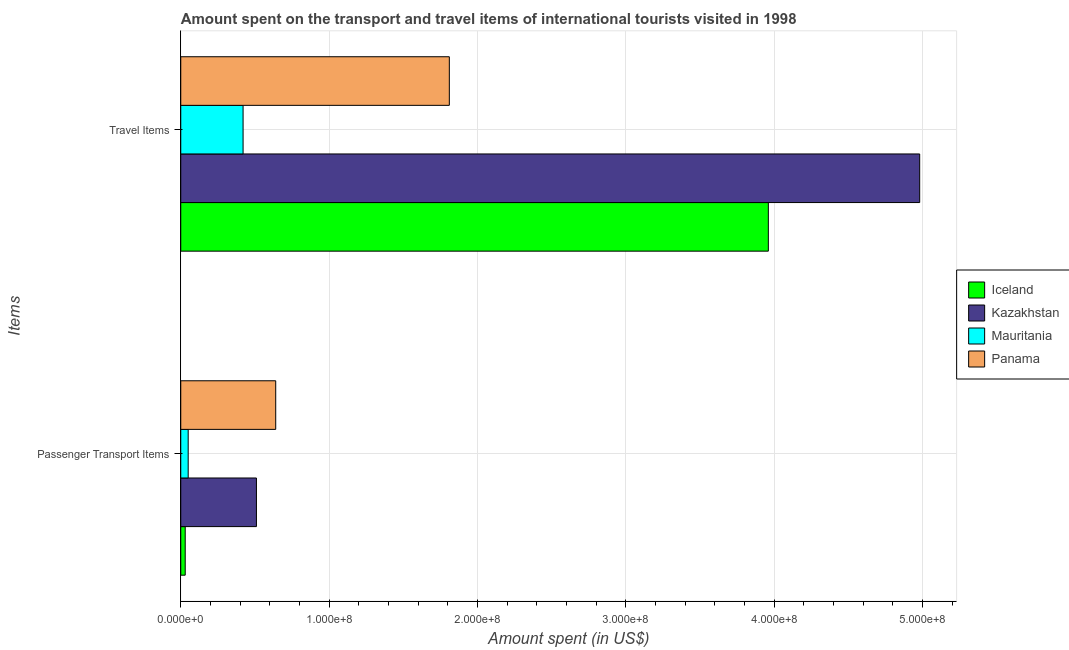How many groups of bars are there?
Offer a very short reply. 2. Are the number of bars per tick equal to the number of legend labels?
Offer a terse response. Yes. How many bars are there on the 2nd tick from the top?
Provide a succinct answer. 4. How many bars are there on the 1st tick from the bottom?
Your answer should be compact. 4. What is the label of the 2nd group of bars from the top?
Keep it short and to the point. Passenger Transport Items. What is the amount spent on passenger transport items in Mauritania?
Your response must be concise. 5.00e+06. Across all countries, what is the maximum amount spent in travel items?
Offer a terse response. 4.98e+08. Across all countries, what is the minimum amount spent on passenger transport items?
Keep it short and to the point. 3.00e+06. In which country was the amount spent in travel items maximum?
Offer a terse response. Kazakhstan. In which country was the amount spent in travel items minimum?
Offer a very short reply. Mauritania. What is the total amount spent in travel items in the graph?
Keep it short and to the point. 1.12e+09. What is the difference between the amount spent on passenger transport items in Mauritania and that in Iceland?
Your response must be concise. 2.00e+06. What is the difference between the amount spent on passenger transport items in Iceland and the amount spent in travel items in Panama?
Provide a succinct answer. -1.78e+08. What is the average amount spent on passenger transport items per country?
Provide a short and direct response. 3.08e+07. What is the difference between the amount spent in travel items and amount spent on passenger transport items in Mauritania?
Keep it short and to the point. 3.70e+07. What is the ratio of the amount spent on passenger transport items in Mauritania to that in Iceland?
Provide a succinct answer. 1.67. Is the amount spent in travel items in Mauritania less than that in Panama?
Provide a short and direct response. Yes. In how many countries, is the amount spent on passenger transport items greater than the average amount spent on passenger transport items taken over all countries?
Offer a very short reply. 2. What does the 3rd bar from the top in Passenger Transport Items represents?
Ensure brevity in your answer.  Kazakhstan. What does the 4th bar from the bottom in Travel Items represents?
Your response must be concise. Panama. Are all the bars in the graph horizontal?
Make the answer very short. Yes. Where does the legend appear in the graph?
Your answer should be compact. Center right. What is the title of the graph?
Your answer should be very brief. Amount spent on the transport and travel items of international tourists visited in 1998. What is the label or title of the X-axis?
Keep it short and to the point. Amount spent (in US$). What is the label or title of the Y-axis?
Ensure brevity in your answer.  Items. What is the Amount spent (in US$) of Kazakhstan in Passenger Transport Items?
Provide a short and direct response. 5.10e+07. What is the Amount spent (in US$) of Mauritania in Passenger Transport Items?
Provide a short and direct response. 5.00e+06. What is the Amount spent (in US$) of Panama in Passenger Transport Items?
Provide a short and direct response. 6.40e+07. What is the Amount spent (in US$) in Iceland in Travel Items?
Provide a short and direct response. 3.96e+08. What is the Amount spent (in US$) in Kazakhstan in Travel Items?
Provide a succinct answer. 4.98e+08. What is the Amount spent (in US$) of Mauritania in Travel Items?
Offer a terse response. 4.20e+07. What is the Amount spent (in US$) of Panama in Travel Items?
Your response must be concise. 1.81e+08. Across all Items, what is the maximum Amount spent (in US$) in Iceland?
Ensure brevity in your answer.  3.96e+08. Across all Items, what is the maximum Amount spent (in US$) in Kazakhstan?
Keep it short and to the point. 4.98e+08. Across all Items, what is the maximum Amount spent (in US$) in Mauritania?
Offer a terse response. 4.20e+07. Across all Items, what is the maximum Amount spent (in US$) in Panama?
Ensure brevity in your answer.  1.81e+08. Across all Items, what is the minimum Amount spent (in US$) in Kazakhstan?
Offer a very short reply. 5.10e+07. Across all Items, what is the minimum Amount spent (in US$) in Panama?
Give a very brief answer. 6.40e+07. What is the total Amount spent (in US$) of Iceland in the graph?
Keep it short and to the point. 3.99e+08. What is the total Amount spent (in US$) of Kazakhstan in the graph?
Make the answer very short. 5.49e+08. What is the total Amount spent (in US$) of Mauritania in the graph?
Offer a terse response. 4.70e+07. What is the total Amount spent (in US$) of Panama in the graph?
Offer a terse response. 2.45e+08. What is the difference between the Amount spent (in US$) in Iceland in Passenger Transport Items and that in Travel Items?
Your answer should be very brief. -3.93e+08. What is the difference between the Amount spent (in US$) in Kazakhstan in Passenger Transport Items and that in Travel Items?
Provide a succinct answer. -4.47e+08. What is the difference between the Amount spent (in US$) in Mauritania in Passenger Transport Items and that in Travel Items?
Give a very brief answer. -3.70e+07. What is the difference between the Amount spent (in US$) in Panama in Passenger Transport Items and that in Travel Items?
Offer a terse response. -1.17e+08. What is the difference between the Amount spent (in US$) of Iceland in Passenger Transport Items and the Amount spent (in US$) of Kazakhstan in Travel Items?
Your answer should be very brief. -4.95e+08. What is the difference between the Amount spent (in US$) in Iceland in Passenger Transport Items and the Amount spent (in US$) in Mauritania in Travel Items?
Your answer should be very brief. -3.90e+07. What is the difference between the Amount spent (in US$) in Iceland in Passenger Transport Items and the Amount spent (in US$) in Panama in Travel Items?
Your response must be concise. -1.78e+08. What is the difference between the Amount spent (in US$) in Kazakhstan in Passenger Transport Items and the Amount spent (in US$) in Mauritania in Travel Items?
Provide a succinct answer. 9.00e+06. What is the difference between the Amount spent (in US$) in Kazakhstan in Passenger Transport Items and the Amount spent (in US$) in Panama in Travel Items?
Keep it short and to the point. -1.30e+08. What is the difference between the Amount spent (in US$) of Mauritania in Passenger Transport Items and the Amount spent (in US$) of Panama in Travel Items?
Give a very brief answer. -1.76e+08. What is the average Amount spent (in US$) of Iceland per Items?
Keep it short and to the point. 2.00e+08. What is the average Amount spent (in US$) in Kazakhstan per Items?
Give a very brief answer. 2.74e+08. What is the average Amount spent (in US$) of Mauritania per Items?
Offer a terse response. 2.35e+07. What is the average Amount spent (in US$) of Panama per Items?
Give a very brief answer. 1.22e+08. What is the difference between the Amount spent (in US$) of Iceland and Amount spent (in US$) of Kazakhstan in Passenger Transport Items?
Make the answer very short. -4.80e+07. What is the difference between the Amount spent (in US$) in Iceland and Amount spent (in US$) in Panama in Passenger Transport Items?
Your response must be concise. -6.10e+07. What is the difference between the Amount spent (in US$) of Kazakhstan and Amount spent (in US$) of Mauritania in Passenger Transport Items?
Your answer should be compact. 4.60e+07. What is the difference between the Amount spent (in US$) of Kazakhstan and Amount spent (in US$) of Panama in Passenger Transport Items?
Your response must be concise. -1.30e+07. What is the difference between the Amount spent (in US$) of Mauritania and Amount spent (in US$) of Panama in Passenger Transport Items?
Your answer should be very brief. -5.90e+07. What is the difference between the Amount spent (in US$) in Iceland and Amount spent (in US$) in Kazakhstan in Travel Items?
Your answer should be compact. -1.02e+08. What is the difference between the Amount spent (in US$) in Iceland and Amount spent (in US$) in Mauritania in Travel Items?
Offer a terse response. 3.54e+08. What is the difference between the Amount spent (in US$) in Iceland and Amount spent (in US$) in Panama in Travel Items?
Make the answer very short. 2.15e+08. What is the difference between the Amount spent (in US$) in Kazakhstan and Amount spent (in US$) in Mauritania in Travel Items?
Make the answer very short. 4.56e+08. What is the difference between the Amount spent (in US$) of Kazakhstan and Amount spent (in US$) of Panama in Travel Items?
Offer a very short reply. 3.17e+08. What is the difference between the Amount spent (in US$) of Mauritania and Amount spent (in US$) of Panama in Travel Items?
Provide a succinct answer. -1.39e+08. What is the ratio of the Amount spent (in US$) in Iceland in Passenger Transport Items to that in Travel Items?
Your response must be concise. 0.01. What is the ratio of the Amount spent (in US$) in Kazakhstan in Passenger Transport Items to that in Travel Items?
Offer a very short reply. 0.1. What is the ratio of the Amount spent (in US$) of Mauritania in Passenger Transport Items to that in Travel Items?
Make the answer very short. 0.12. What is the ratio of the Amount spent (in US$) in Panama in Passenger Transport Items to that in Travel Items?
Ensure brevity in your answer.  0.35. What is the difference between the highest and the second highest Amount spent (in US$) in Iceland?
Keep it short and to the point. 3.93e+08. What is the difference between the highest and the second highest Amount spent (in US$) of Kazakhstan?
Keep it short and to the point. 4.47e+08. What is the difference between the highest and the second highest Amount spent (in US$) in Mauritania?
Offer a terse response. 3.70e+07. What is the difference between the highest and the second highest Amount spent (in US$) in Panama?
Offer a very short reply. 1.17e+08. What is the difference between the highest and the lowest Amount spent (in US$) in Iceland?
Your answer should be very brief. 3.93e+08. What is the difference between the highest and the lowest Amount spent (in US$) in Kazakhstan?
Keep it short and to the point. 4.47e+08. What is the difference between the highest and the lowest Amount spent (in US$) in Mauritania?
Make the answer very short. 3.70e+07. What is the difference between the highest and the lowest Amount spent (in US$) of Panama?
Offer a terse response. 1.17e+08. 